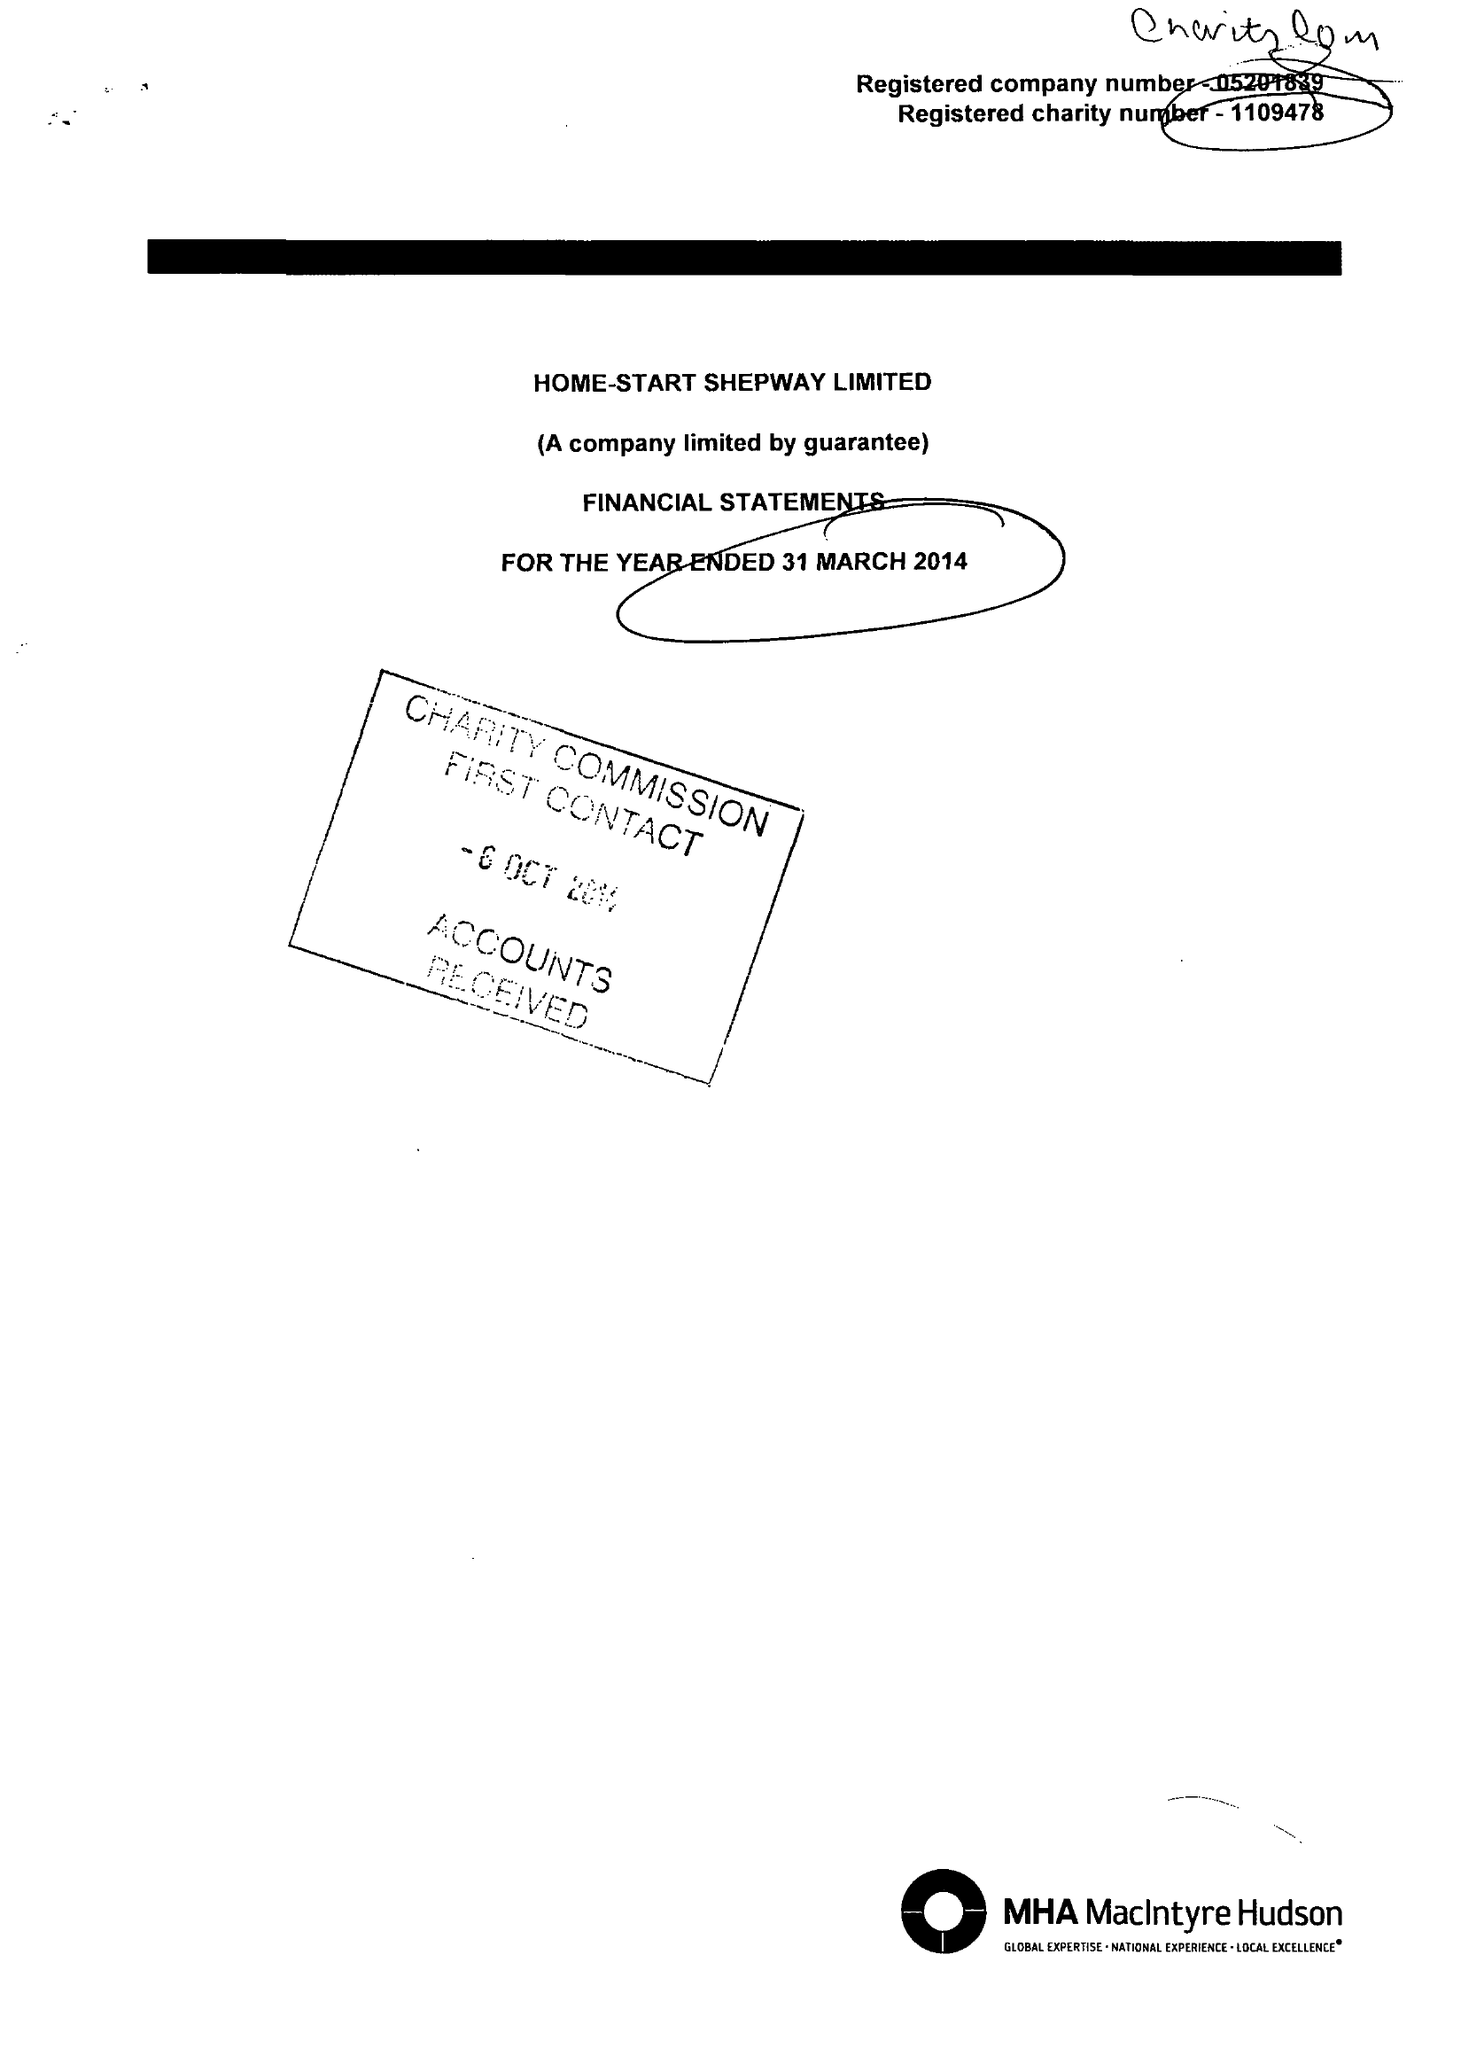What is the value for the spending_annually_in_british_pounds?
Answer the question using a single word or phrase. 270128.00 